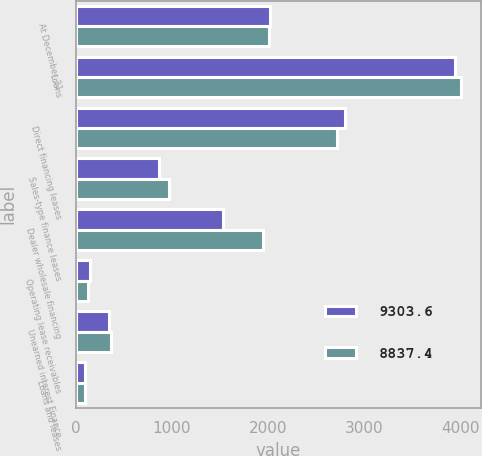<chart> <loc_0><loc_0><loc_500><loc_500><stacked_bar_chart><ecel><fcel>At December 31<fcel>Loans<fcel>Direct financing leases<fcel>Sales-type finance leases<fcel>Dealer wholesale financing<fcel>Operating lease receivables<fcel>Unearned interest Finance<fcel>Loans and leases<nl><fcel>9303.6<fcel>2016<fcel>3948.6<fcel>2798<fcel>867.3<fcel>1528.5<fcel>150.9<fcel>344.7<fcel>97.1<nl><fcel>8837.4<fcel>2015<fcel>4011.7<fcel>2719.5<fcel>969.8<fcel>1950.1<fcel>131.9<fcel>364.6<fcel>99.2<nl></chart> 